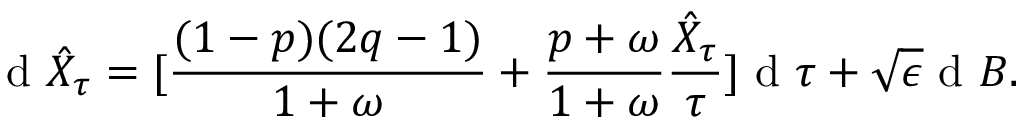<formula> <loc_0><loc_0><loc_500><loc_500>d \hat { X } _ { \tau } = [ \frac { ( 1 - p ) ( 2 q - 1 ) } { 1 + \omega } + \frac { p + \omega } { 1 + \omega } \frac { \hat { X } _ { \tau } } { \tau } ] d \tau + \sqrt { \epsilon } d B .</formula> 